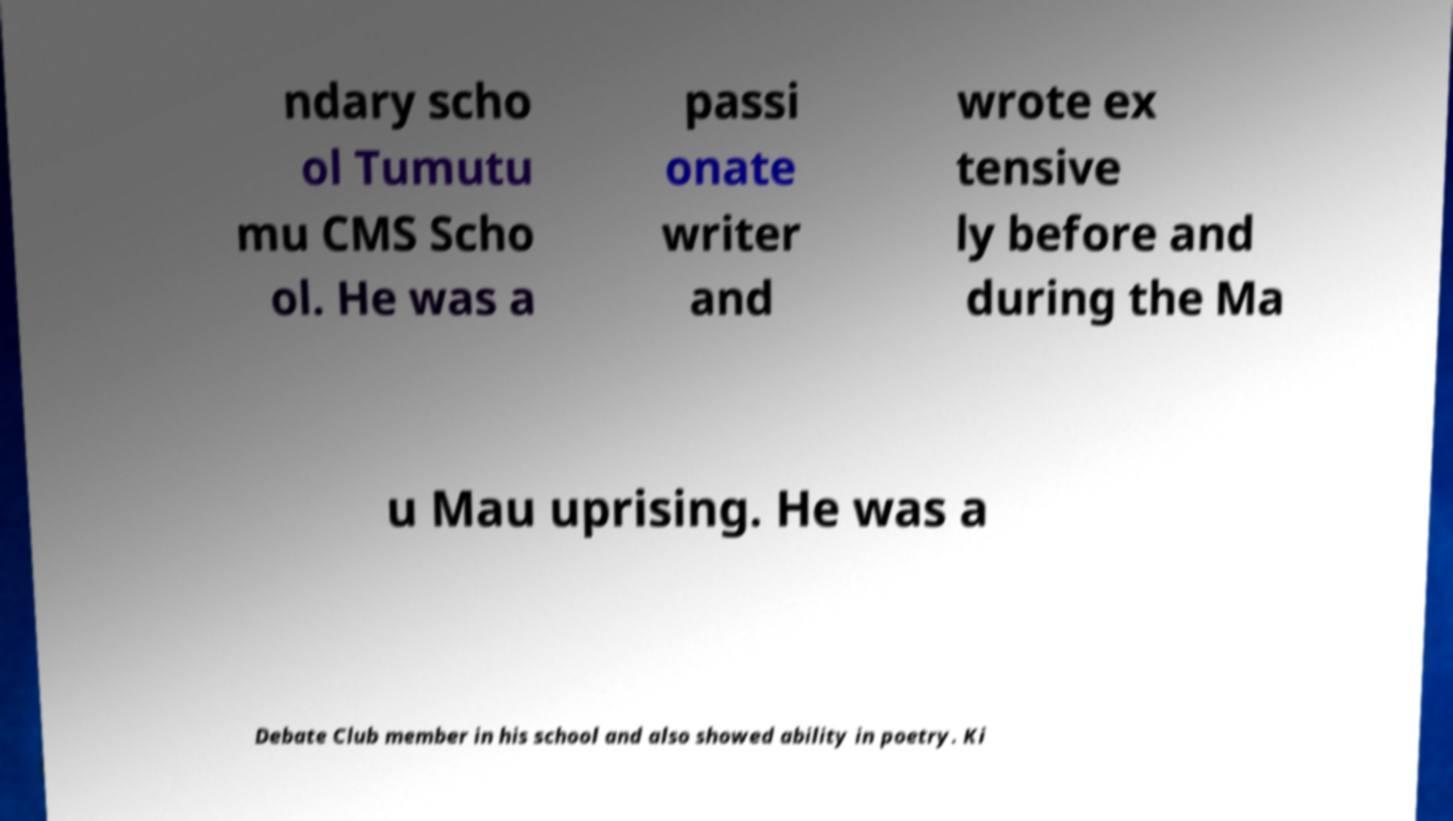Could you assist in decoding the text presented in this image and type it out clearly? ndary scho ol Tumutu mu CMS Scho ol. He was a passi onate writer and wrote ex tensive ly before and during the Ma u Mau uprising. He was a Debate Club member in his school and also showed ability in poetry. Ki 